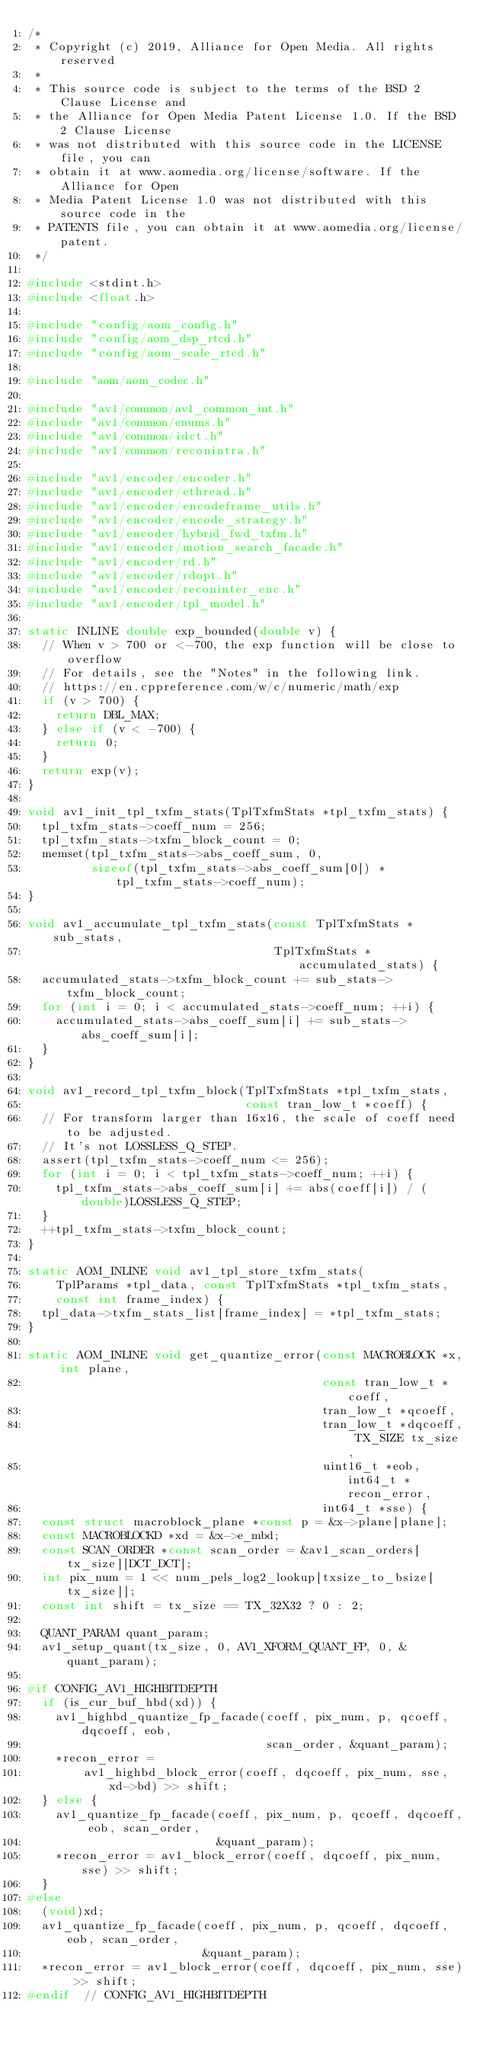<code> <loc_0><loc_0><loc_500><loc_500><_C_>/*
 * Copyright (c) 2019, Alliance for Open Media. All rights reserved
 *
 * This source code is subject to the terms of the BSD 2 Clause License and
 * the Alliance for Open Media Patent License 1.0. If the BSD 2 Clause License
 * was not distributed with this source code in the LICENSE file, you can
 * obtain it at www.aomedia.org/license/software. If the Alliance for Open
 * Media Patent License 1.0 was not distributed with this source code in the
 * PATENTS file, you can obtain it at www.aomedia.org/license/patent.
 */

#include <stdint.h>
#include <float.h>

#include "config/aom_config.h"
#include "config/aom_dsp_rtcd.h"
#include "config/aom_scale_rtcd.h"

#include "aom/aom_codec.h"

#include "av1/common/av1_common_int.h"
#include "av1/common/enums.h"
#include "av1/common/idct.h"
#include "av1/common/reconintra.h"

#include "av1/encoder/encoder.h"
#include "av1/encoder/ethread.h"
#include "av1/encoder/encodeframe_utils.h"
#include "av1/encoder/encode_strategy.h"
#include "av1/encoder/hybrid_fwd_txfm.h"
#include "av1/encoder/motion_search_facade.h"
#include "av1/encoder/rd.h"
#include "av1/encoder/rdopt.h"
#include "av1/encoder/reconinter_enc.h"
#include "av1/encoder/tpl_model.h"

static INLINE double exp_bounded(double v) {
  // When v > 700 or <-700, the exp function will be close to overflow
  // For details, see the "Notes" in the following link.
  // https://en.cppreference.com/w/c/numeric/math/exp
  if (v > 700) {
    return DBL_MAX;
  } else if (v < -700) {
    return 0;
  }
  return exp(v);
}

void av1_init_tpl_txfm_stats(TplTxfmStats *tpl_txfm_stats) {
  tpl_txfm_stats->coeff_num = 256;
  tpl_txfm_stats->txfm_block_count = 0;
  memset(tpl_txfm_stats->abs_coeff_sum, 0,
         sizeof(tpl_txfm_stats->abs_coeff_sum[0]) * tpl_txfm_stats->coeff_num);
}

void av1_accumulate_tpl_txfm_stats(const TplTxfmStats *sub_stats,
                                   TplTxfmStats *accumulated_stats) {
  accumulated_stats->txfm_block_count += sub_stats->txfm_block_count;
  for (int i = 0; i < accumulated_stats->coeff_num; ++i) {
    accumulated_stats->abs_coeff_sum[i] += sub_stats->abs_coeff_sum[i];
  }
}

void av1_record_tpl_txfm_block(TplTxfmStats *tpl_txfm_stats,
                               const tran_low_t *coeff) {
  // For transform larger than 16x16, the scale of coeff need to be adjusted.
  // It's not LOSSLESS_Q_STEP.
  assert(tpl_txfm_stats->coeff_num <= 256);
  for (int i = 0; i < tpl_txfm_stats->coeff_num; ++i) {
    tpl_txfm_stats->abs_coeff_sum[i] += abs(coeff[i]) / (double)LOSSLESS_Q_STEP;
  }
  ++tpl_txfm_stats->txfm_block_count;
}

static AOM_INLINE void av1_tpl_store_txfm_stats(
    TplParams *tpl_data, const TplTxfmStats *tpl_txfm_stats,
    const int frame_index) {
  tpl_data->txfm_stats_list[frame_index] = *tpl_txfm_stats;
}

static AOM_INLINE void get_quantize_error(const MACROBLOCK *x, int plane,
                                          const tran_low_t *coeff,
                                          tran_low_t *qcoeff,
                                          tran_low_t *dqcoeff, TX_SIZE tx_size,
                                          uint16_t *eob, int64_t *recon_error,
                                          int64_t *sse) {
  const struct macroblock_plane *const p = &x->plane[plane];
  const MACROBLOCKD *xd = &x->e_mbd;
  const SCAN_ORDER *const scan_order = &av1_scan_orders[tx_size][DCT_DCT];
  int pix_num = 1 << num_pels_log2_lookup[txsize_to_bsize[tx_size]];
  const int shift = tx_size == TX_32X32 ? 0 : 2;

  QUANT_PARAM quant_param;
  av1_setup_quant(tx_size, 0, AV1_XFORM_QUANT_FP, 0, &quant_param);

#if CONFIG_AV1_HIGHBITDEPTH
  if (is_cur_buf_hbd(xd)) {
    av1_highbd_quantize_fp_facade(coeff, pix_num, p, qcoeff, dqcoeff, eob,
                                  scan_order, &quant_param);
    *recon_error =
        av1_highbd_block_error(coeff, dqcoeff, pix_num, sse, xd->bd) >> shift;
  } else {
    av1_quantize_fp_facade(coeff, pix_num, p, qcoeff, dqcoeff, eob, scan_order,
                           &quant_param);
    *recon_error = av1_block_error(coeff, dqcoeff, pix_num, sse) >> shift;
  }
#else
  (void)xd;
  av1_quantize_fp_facade(coeff, pix_num, p, qcoeff, dqcoeff, eob, scan_order,
                         &quant_param);
  *recon_error = av1_block_error(coeff, dqcoeff, pix_num, sse) >> shift;
#endif  // CONFIG_AV1_HIGHBITDEPTH
</code> 